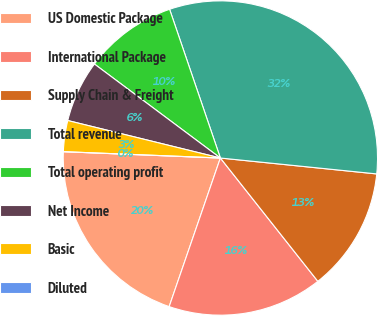Convert chart. <chart><loc_0><loc_0><loc_500><loc_500><pie_chart><fcel>US Domestic Package<fcel>International Package<fcel>Supply Chain & Freight<fcel>Total revenue<fcel>Total operating profit<fcel>Net Income<fcel>Basic<fcel>Diluted<nl><fcel>20.36%<fcel>15.93%<fcel>12.74%<fcel>31.85%<fcel>9.56%<fcel>6.37%<fcel>3.19%<fcel>0.0%<nl></chart> 